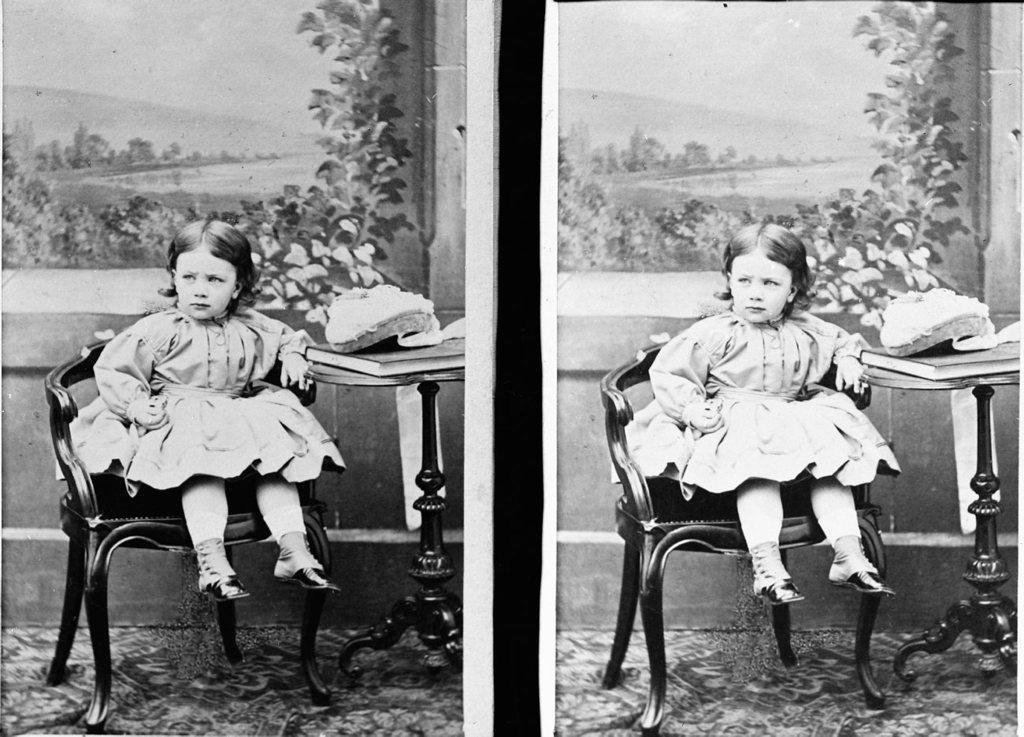In one or two sentences, can you explain what this image depicts? This is a collage of two similar pictures we see a girl seated on the chair and we see a book on the table 